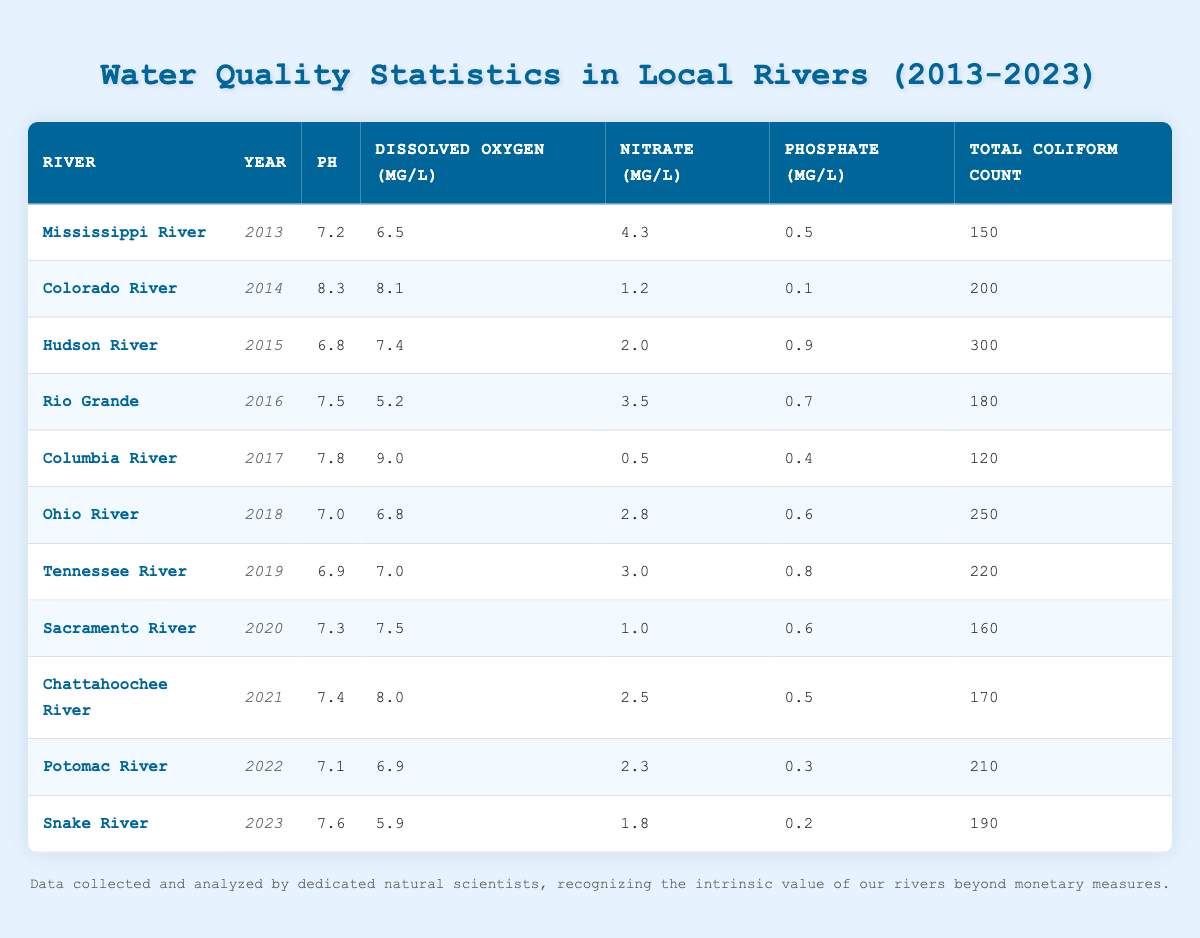What was the pH level of the Columbia River in 2017? By looking at the table and locating the row for the Columbia River in the year 2017, we can find that the pH level listed is 7.8.
Answer: 7.8 Which river had the highest total coliform count, and what was that count? Scanning through the Total Coliform Count column for each river, the Hudson River in 2015 has the highest count listed at 300.
Answer: Hudson River, 300 What is the average dissolved oxygen level across all rivers in the last decade? To find the average, add up the dissolved oxygen levels: (6.5 + 8.1 + 7.4 + 5.2 + 9.0 + 6.8 + 7.0 + 7.5 + 8.0 + 6.9 + 5.9) = 77.1. There are 11 data points, so the average is 77.1/11 = 7.01.
Answer: 7.01 Is the nitrate level in the Snake River in 2023 less than 2 mg/L? According to the table, the nitrate level for the Snake River in 2023 is listed as 1.8 mg/L, which is less than 2 mg/L. Thus, the statement is true.
Answer: Yes Which river had the lowest phosphate level, and what was that level? By examining the Phosphate column, the lowest value is 0.1 mg/L, which belongs to the Colorado River in 2014.
Answer: Colorado River, 0.1 